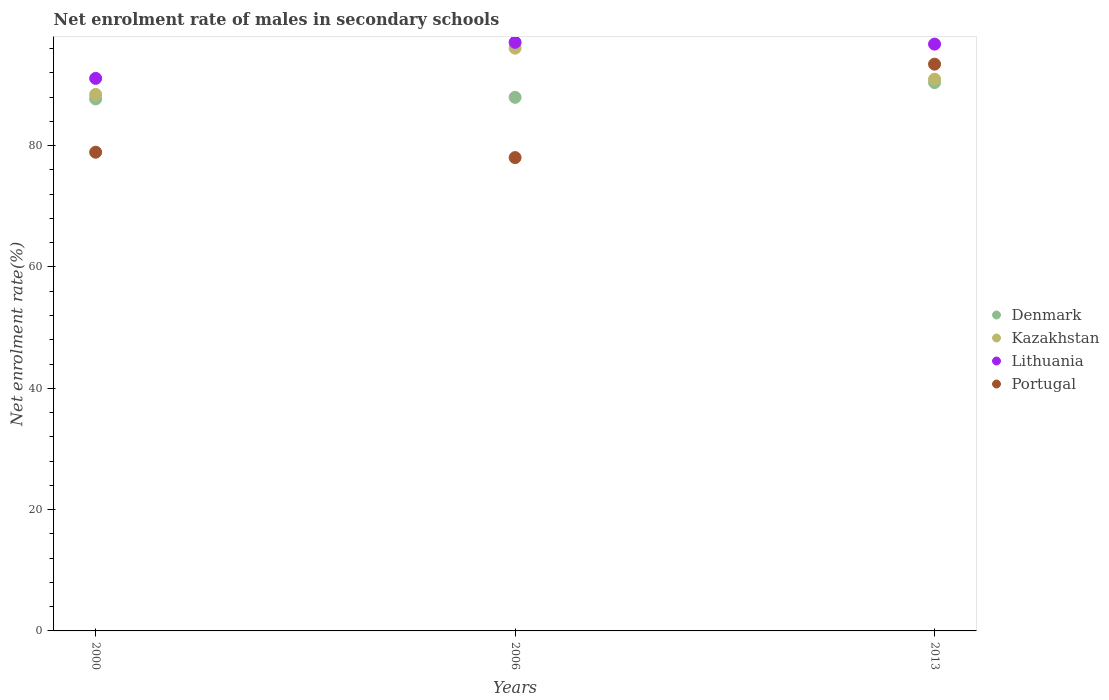How many different coloured dotlines are there?
Your answer should be very brief. 4. Is the number of dotlines equal to the number of legend labels?
Ensure brevity in your answer.  Yes. What is the net enrolment rate of males in secondary schools in Kazakhstan in 2006?
Give a very brief answer. 96.07. Across all years, what is the maximum net enrolment rate of males in secondary schools in Portugal?
Give a very brief answer. 93.43. Across all years, what is the minimum net enrolment rate of males in secondary schools in Denmark?
Keep it short and to the point. 87.7. In which year was the net enrolment rate of males in secondary schools in Lithuania minimum?
Your answer should be very brief. 2000. What is the total net enrolment rate of males in secondary schools in Denmark in the graph?
Give a very brief answer. 266.06. What is the difference between the net enrolment rate of males in secondary schools in Denmark in 2000 and that in 2006?
Provide a short and direct response. -0.26. What is the difference between the net enrolment rate of males in secondary schools in Kazakhstan in 2006 and the net enrolment rate of males in secondary schools in Portugal in 2013?
Offer a very short reply. 2.63. What is the average net enrolment rate of males in secondary schools in Denmark per year?
Make the answer very short. 88.69. In the year 2013, what is the difference between the net enrolment rate of males in secondary schools in Kazakhstan and net enrolment rate of males in secondary schools in Lithuania?
Your answer should be compact. -5.78. What is the ratio of the net enrolment rate of males in secondary schools in Lithuania in 2000 to that in 2013?
Offer a terse response. 0.94. What is the difference between the highest and the second highest net enrolment rate of males in secondary schools in Lithuania?
Offer a very short reply. 0.29. What is the difference between the highest and the lowest net enrolment rate of males in secondary schools in Lithuania?
Keep it short and to the point. 5.94. In how many years, is the net enrolment rate of males in secondary schools in Lithuania greater than the average net enrolment rate of males in secondary schools in Lithuania taken over all years?
Your answer should be compact. 2. Is the sum of the net enrolment rate of males in secondary schools in Denmark in 2000 and 2006 greater than the maximum net enrolment rate of males in secondary schools in Portugal across all years?
Keep it short and to the point. Yes. Is the net enrolment rate of males in secondary schools in Portugal strictly less than the net enrolment rate of males in secondary schools in Lithuania over the years?
Keep it short and to the point. Yes. How many dotlines are there?
Provide a succinct answer. 4. Are the values on the major ticks of Y-axis written in scientific E-notation?
Provide a succinct answer. No. Does the graph contain any zero values?
Keep it short and to the point. No. Does the graph contain grids?
Offer a terse response. No. How are the legend labels stacked?
Keep it short and to the point. Vertical. What is the title of the graph?
Offer a very short reply. Net enrolment rate of males in secondary schools. Does "Libya" appear as one of the legend labels in the graph?
Make the answer very short. No. What is the label or title of the X-axis?
Your answer should be very brief. Years. What is the label or title of the Y-axis?
Make the answer very short. Net enrolment rate(%). What is the Net enrolment rate(%) of Denmark in 2000?
Your response must be concise. 87.7. What is the Net enrolment rate(%) of Kazakhstan in 2000?
Offer a very short reply. 88.45. What is the Net enrolment rate(%) of Lithuania in 2000?
Give a very brief answer. 91.09. What is the Net enrolment rate(%) of Portugal in 2000?
Your answer should be very brief. 78.92. What is the Net enrolment rate(%) of Denmark in 2006?
Make the answer very short. 87.96. What is the Net enrolment rate(%) in Kazakhstan in 2006?
Your answer should be compact. 96.07. What is the Net enrolment rate(%) of Lithuania in 2006?
Offer a terse response. 97.03. What is the Net enrolment rate(%) in Portugal in 2006?
Your answer should be very brief. 78.03. What is the Net enrolment rate(%) of Denmark in 2013?
Offer a terse response. 90.39. What is the Net enrolment rate(%) of Kazakhstan in 2013?
Give a very brief answer. 90.96. What is the Net enrolment rate(%) of Lithuania in 2013?
Keep it short and to the point. 96.74. What is the Net enrolment rate(%) in Portugal in 2013?
Ensure brevity in your answer.  93.43. Across all years, what is the maximum Net enrolment rate(%) of Denmark?
Offer a very short reply. 90.39. Across all years, what is the maximum Net enrolment rate(%) of Kazakhstan?
Make the answer very short. 96.07. Across all years, what is the maximum Net enrolment rate(%) of Lithuania?
Offer a very short reply. 97.03. Across all years, what is the maximum Net enrolment rate(%) in Portugal?
Your answer should be very brief. 93.43. Across all years, what is the minimum Net enrolment rate(%) in Denmark?
Ensure brevity in your answer.  87.7. Across all years, what is the minimum Net enrolment rate(%) in Kazakhstan?
Your answer should be compact. 88.45. Across all years, what is the minimum Net enrolment rate(%) of Lithuania?
Your response must be concise. 91.09. Across all years, what is the minimum Net enrolment rate(%) of Portugal?
Your response must be concise. 78.03. What is the total Net enrolment rate(%) of Denmark in the graph?
Your response must be concise. 266.06. What is the total Net enrolment rate(%) in Kazakhstan in the graph?
Your response must be concise. 275.47. What is the total Net enrolment rate(%) in Lithuania in the graph?
Your answer should be compact. 284.86. What is the total Net enrolment rate(%) in Portugal in the graph?
Provide a short and direct response. 250.38. What is the difference between the Net enrolment rate(%) in Denmark in 2000 and that in 2006?
Offer a very short reply. -0.26. What is the difference between the Net enrolment rate(%) of Kazakhstan in 2000 and that in 2006?
Keep it short and to the point. -7.62. What is the difference between the Net enrolment rate(%) in Lithuania in 2000 and that in 2006?
Offer a terse response. -5.94. What is the difference between the Net enrolment rate(%) of Portugal in 2000 and that in 2006?
Provide a succinct answer. 0.89. What is the difference between the Net enrolment rate(%) of Denmark in 2000 and that in 2013?
Offer a terse response. -2.69. What is the difference between the Net enrolment rate(%) in Kazakhstan in 2000 and that in 2013?
Ensure brevity in your answer.  -2.51. What is the difference between the Net enrolment rate(%) in Lithuania in 2000 and that in 2013?
Your answer should be very brief. -5.65. What is the difference between the Net enrolment rate(%) of Portugal in 2000 and that in 2013?
Ensure brevity in your answer.  -14.52. What is the difference between the Net enrolment rate(%) of Denmark in 2006 and that in 2013?
Give a very brief answer. -2.43. What is the difference between the Net enrolment rate(%) of Kazakhstan in 2006 and that in 2013?
Your answer should be compact. 5.11. What is the difference between the Net enrolment rate(%) of Lithuania in 2006 and that in 2013?
Your response must be concise. 0.29. What is the difference between the Net enrolment rate(%) of Portugal in 2006 and that in 2013?
Your response must be concise. -15.4. What is the difference between the Net enrolment rate(%) in Denmark in 2000 and the Net enrolment rate(%) in Kazakhstan in 2006?
Make the answer very short. -8.37. What is the difference between the Net enrolment rate(%) of Denmark in 2000 and the Net enrolment rate(%) of Lithuania in 2006?
Offer a very short reply. -9.33. What is the difference between the Net enrolment rate(%) in Denmark in 2000 and the Net enrolment rate(%) in Portugal in 2006?
Your answer should be compact. 9.67. What is the difference between the Net enrolment rate(%) of Kazakhstan in 2000 and the Net enrolment rate(%) of Lithuania in 2006?
Make the answer very short. -8.58. What is the difference between the Net enrolment rate(%) in Kazakhstan in 2000 and the Net enrolment rate(%) in Portugal in 2006?
Provide a short and direct response. 10.42. What is the difference between the Net enrolment rate(%) of Lithuania in 2000 and the Net enrolment rate(%) of Portugal in 2006?
Keep it short and to the point. 13.06. What is the difference between the Net enrolment rate(%) in Denmark in 2000 and the Net enrolment rate(%) in Kazakhstan in 2013?
Keep it short and to the point. -3.25. What is the difference between the Net enrolment rate(%) of Denmark in 2000 and the Net enrolment rate(%) of Lithuania in 2013?
Provide a short and direct response. -9.03. What is the difference between the Net enrolment rate(%) of Denmark in 2000 and the Net enrolment rate(%) of Portugal in 2013?
Provide a succinct answer. -5.73. What is the difference between the Net enrolment rate(%) in Kazakhstan in 2000 and the Net enrolment rate(%) in Lithuania in 2013?
Your response must be concise. -8.29. What is the difference between the Net enrolment rate(%) in Kazakhstan in 2000 and the Net enrolment rate(%) in Portugal in 2013?
Your answer should be very brief. -4.98. What is the difference between the Net enrolment rate(%) in Lithuania in 2000 and the Net enrolment rate(%) in Portugal in 2013?
Give a very brief answer. -2.35. What is the difference between the Net enrolment rate(%) in Denmark in 2006 and the Net enrolment rate(%) in Kazakhstan in 2013?
Give a very brief answer. -2.99. What is the difference between the Net enrolment rate(%) of Denmark in 2006 and the Net enrolment rate(%) of Lithuania in 2013?
Offer a very short reply. -8.77. What is the difference between the Net enrolment rate(%) in Denmark in 2006 and the Net enrolment rate(%) in Portugal in 2013?
Make the answer very short. -5.47. What is the difference between the Net enrolment rate(%) in Kazakhstan in 2006 and the Net enrolment rate(%) in Lithuania in 2013?
Offer a terse response. -0.67. What is the difference between the Net enrolment rate(%) in Kazakhstan in 2006 and the Net enrolment rate(%) in Portugal in 2013?
Give a very brief answer. 2.63. What is the difference between the Net enrolment rate(%) in Lithuania in 2006 and the Net enrolment rate(%) in Portugal in 2013?
Ensure brevity in your answer.  3.6. What is the average Net enrolment rate(%) in Denmark per year?
Your answer should be very brief. 88.69. What is the average Net enrolment rate(%) in Kazakhstan per year?
Ensure brevity in your answer.  91.82. What is the average Net enrolment rate(%) in Lithuania per year?
Keep it short and to the point. 94.95. What is the average Net enrolment rate(%) in Portugal per year?
Make the answer very short. 83.46. In the year 2000, what is the difference between the Net enrolment rate(%) of Denmark and Net enrolment rate(%) of Kazakhstan?
Your answer should be compact. -0.75. In the year 2000, what is the difference between the Net enrolment rate(%) of Denmark and Net enrolment rate(%) of Lithuania?
Keep it short and to the point. -3.39. In the year 2000, what is the difference between the Net enrolment rate(%) in Denmark and Net enrolment rate(%) in Portugal?
Provide a short and direct response. 8.78. In the year 2000, what is the difference between the Net enrolment rate(%) in Kazakhstan and Net enrolment rate(%) in Lithuania?
Offer a terse response. -2.64. In the year 2000, what is the difference between the Net enrolment rate(%) in Kazakhstan and Net enrolment rate(%) in Portugal?
Make the answer very short. 9.53. In the year 2000, what is the difference between the Net enrolment rate(%) of Lithuania and Net enrolment rate(%) of Portugal?
Your answer should be compact. 12.17. In the year 2006, what is the difference between the Net enrolment rate(%) of Denmark and Net enrolment rate(%) of Kazakhstan?
Offer a terse response. -8.11. In the year 2006, what is the difference between the Net enrolment rate(%) of Denmark and Net enrolment rate(%) of Lithuania?
Offer a terse response. -9.07. In the year 2006, what is the difference between the Net enrolment rate(%) of Denmark and Net enrolment rate(%) of Portugal?
Your answer should be compact. 9.93. In the year 2006, what is the difference between the Net enrolment rate(%) of Kazakhstan and Net enrolment rate(%) of Lithuania?
Provide a succinct answer. -0.96. In the year 2006, what is the difference between the Net enrolment rate(%) in Kazakhstan and Net enrolment rate(%) in Portugal?
Offer a terse response. 18.04. In the year 2006, what is the difference between the Net enrolment rate(%) of Lithuania and Net enrolment rate(%) of Portugal?
Your response must be concise. 19. In the year 2013, what is the difference between the Net enrolment rate(%) of Denmark and Net enrolment rate(%) of Kazakhstan?
Ensure brevity in your answer.  -0.56. In the year 2013, what is the difference between the Net enrolment rate(%) of Denmark and Net enrolment rate(%) of Lithuania?
Give a very brief answer. -6.35. In the year 2013, what is the difference between the Net enrolment rate(%) in Denmark and Net enrolment rate(%) in Portugal?
Offer a terse response. -3.04. In the year 2013, what is the difference between the Net enrolment rate(%) in Kazakhstan and Net enrolment rate(%) in Lithuania?
Offer a very short reply. -5.78. In the year 2013, what is the difference between the Net enrolment rate(%) in Kazakhstan and Net enrolment rate(%) in Portugal?
Make the answer very short. -2.48. In the year 2013, what is the difference between the Net enrolment rate(%) in Lithuania and Net enrolment rate(%) in Portugal?
Give a very brief answer. 3.3. What is the ratio of the Net enrolment rate(%) in Kazakhstan in 2000 to that in 2006?
Offer a terse response. 0.92. What is the ratio of the Net enrolment rate(%) in Lithuania in 2000 to that in 2006?
Ensure brevity in your answer.  0.94. What is the ratio of the Net enrolment rate(%) in Portugal in 2000 to that in 2006?
Keep it short and to the point. 1.01. What is the ratio of the Net enrolment rate(%) in Denmark in 2000 to that in 2013?
Offer a terse response. 0.97. What is the ratio of the Net enrolment rate(%) of Kazakhstan in 2000 to that in 2013?
Your response must be concise. 0.97. What is the ratio of the Net enrolment rate(%) of Lithuania in 2000 to that in 2013?
Ensure brevity in your answer.  0.94. What is the ratio of the Net enrolment rate(%) in Portugal in 2000 to that in 2013?
Your answer should be very brief. 0.84. What is the ratio of the Net enrolment rate(%) in Denmark in 2006 to that in 2013?
Offer a very short reply. 0.97. What is the ratio of the Net enrolment rate(%) in Kazakhstan in 2006 to that in 2013?
Provide a short and direct response. 1.06. What is the ratio of the Net enrolment rate(%) of Lithuania in 2006 to that in 2013?
Your response must be concise. 1. What is the ratio of the Net enrolment rate(%) in Portugal in 2006 to that in 2013?
Give a very brief answer. 0.84. What is the difference between the highest and the second highest Net enrolment rate(%) of Denmark?
Provide a short and direct response. 2.43. What is the difference between the highest and the second highest Net enrolment rate(%) in Kazakhstan?
Ensure brevity in your answer.  5.11. What is the difference between the highest and the second highest Net enrolment rate(%) of Lithuania?
Give a very brief answer. 0.29. What is the difference between the highest and the second highest Net enrolment rate(%) of Portugal?
Make the answer very short. 14.52. What is the difference between the highest and the lowest Net enrolment rate(%) in Denmark?
Your answer should be compact. 2.69. What is the difference between the highest and the lowest Net enrolment rate(%) of Kazakhstan?
Your response must be concise. 7.62. What is the difference between the highest and the lowest Net enrolment rate(%) of Lithuania?
Keep it short and to the point. 5.94. What is the difference between the highest and the lowest Net enrolment rate(%) in Portugal?
Your answer should be very brief. 15.4. 